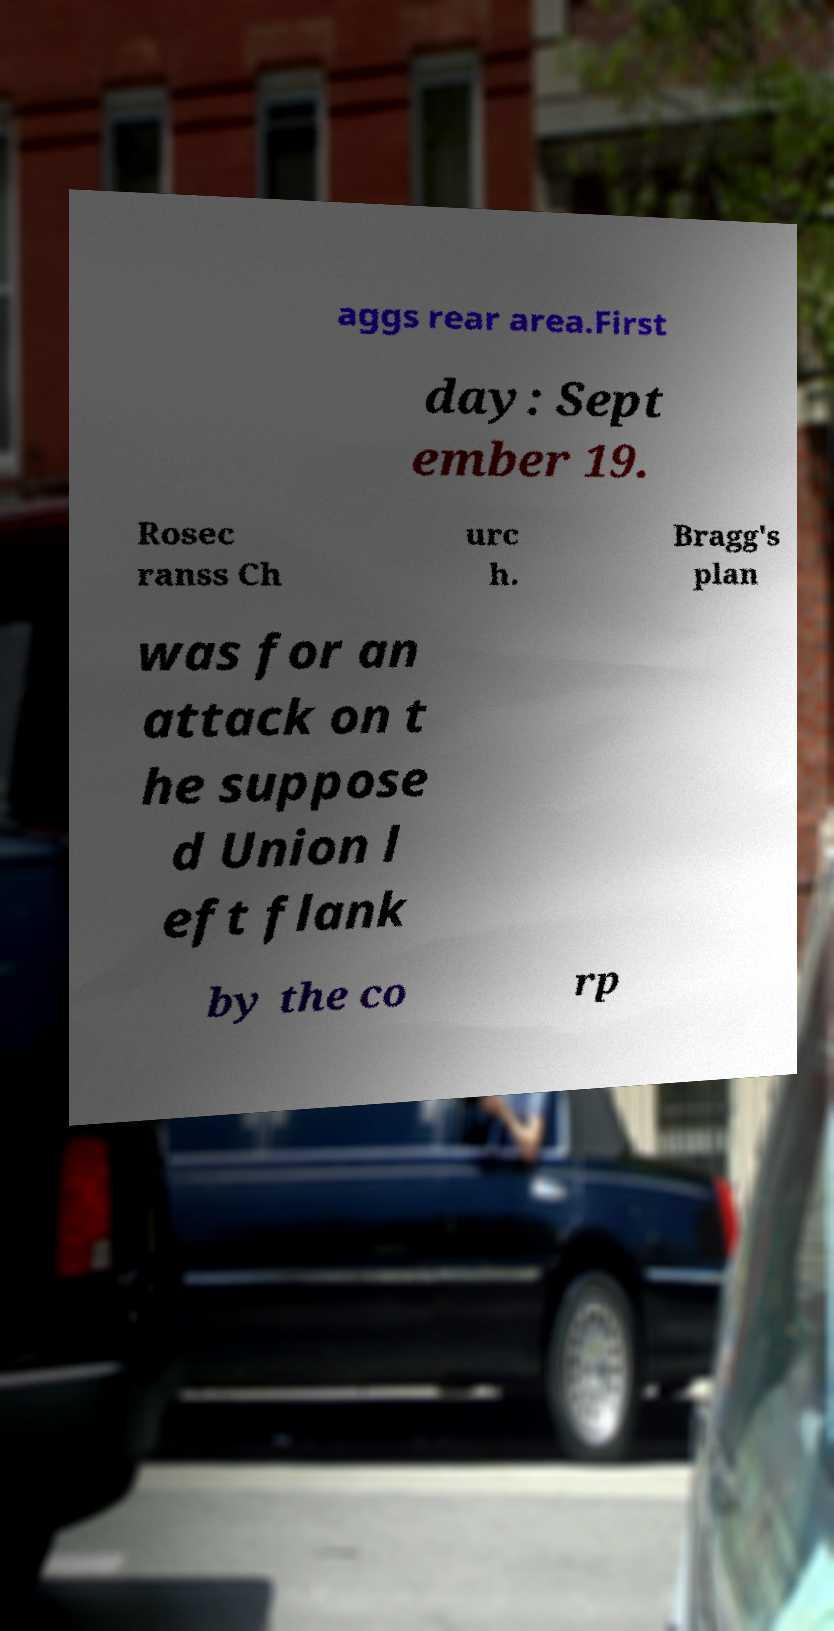Could you assist in decoding the text presented in this image and type it out clearly? aggs rear area.First day: Sept ember 19. Rosec ranss Ch urc h. Bragg's plan was for an attack on t he suppose d Union l eft flank by the co rp 